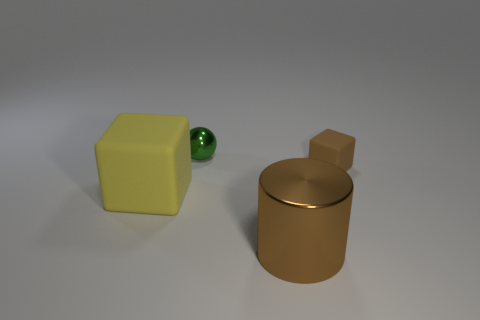Add 3 brown metallic things. How many objects exist? 7 Subtract all cylinders. How many objects are left? 3 Subtract all big gray matte objects. Subtract all metal things. How many objects are left? 2 Add 2 big yellow cubes. How many big yellow cubes are left? 3 Add 1 large gray shiny balls. How many large gray shiny balls exist? 1 Subtract 0 yellow cylinders. How many objects are left? 4 